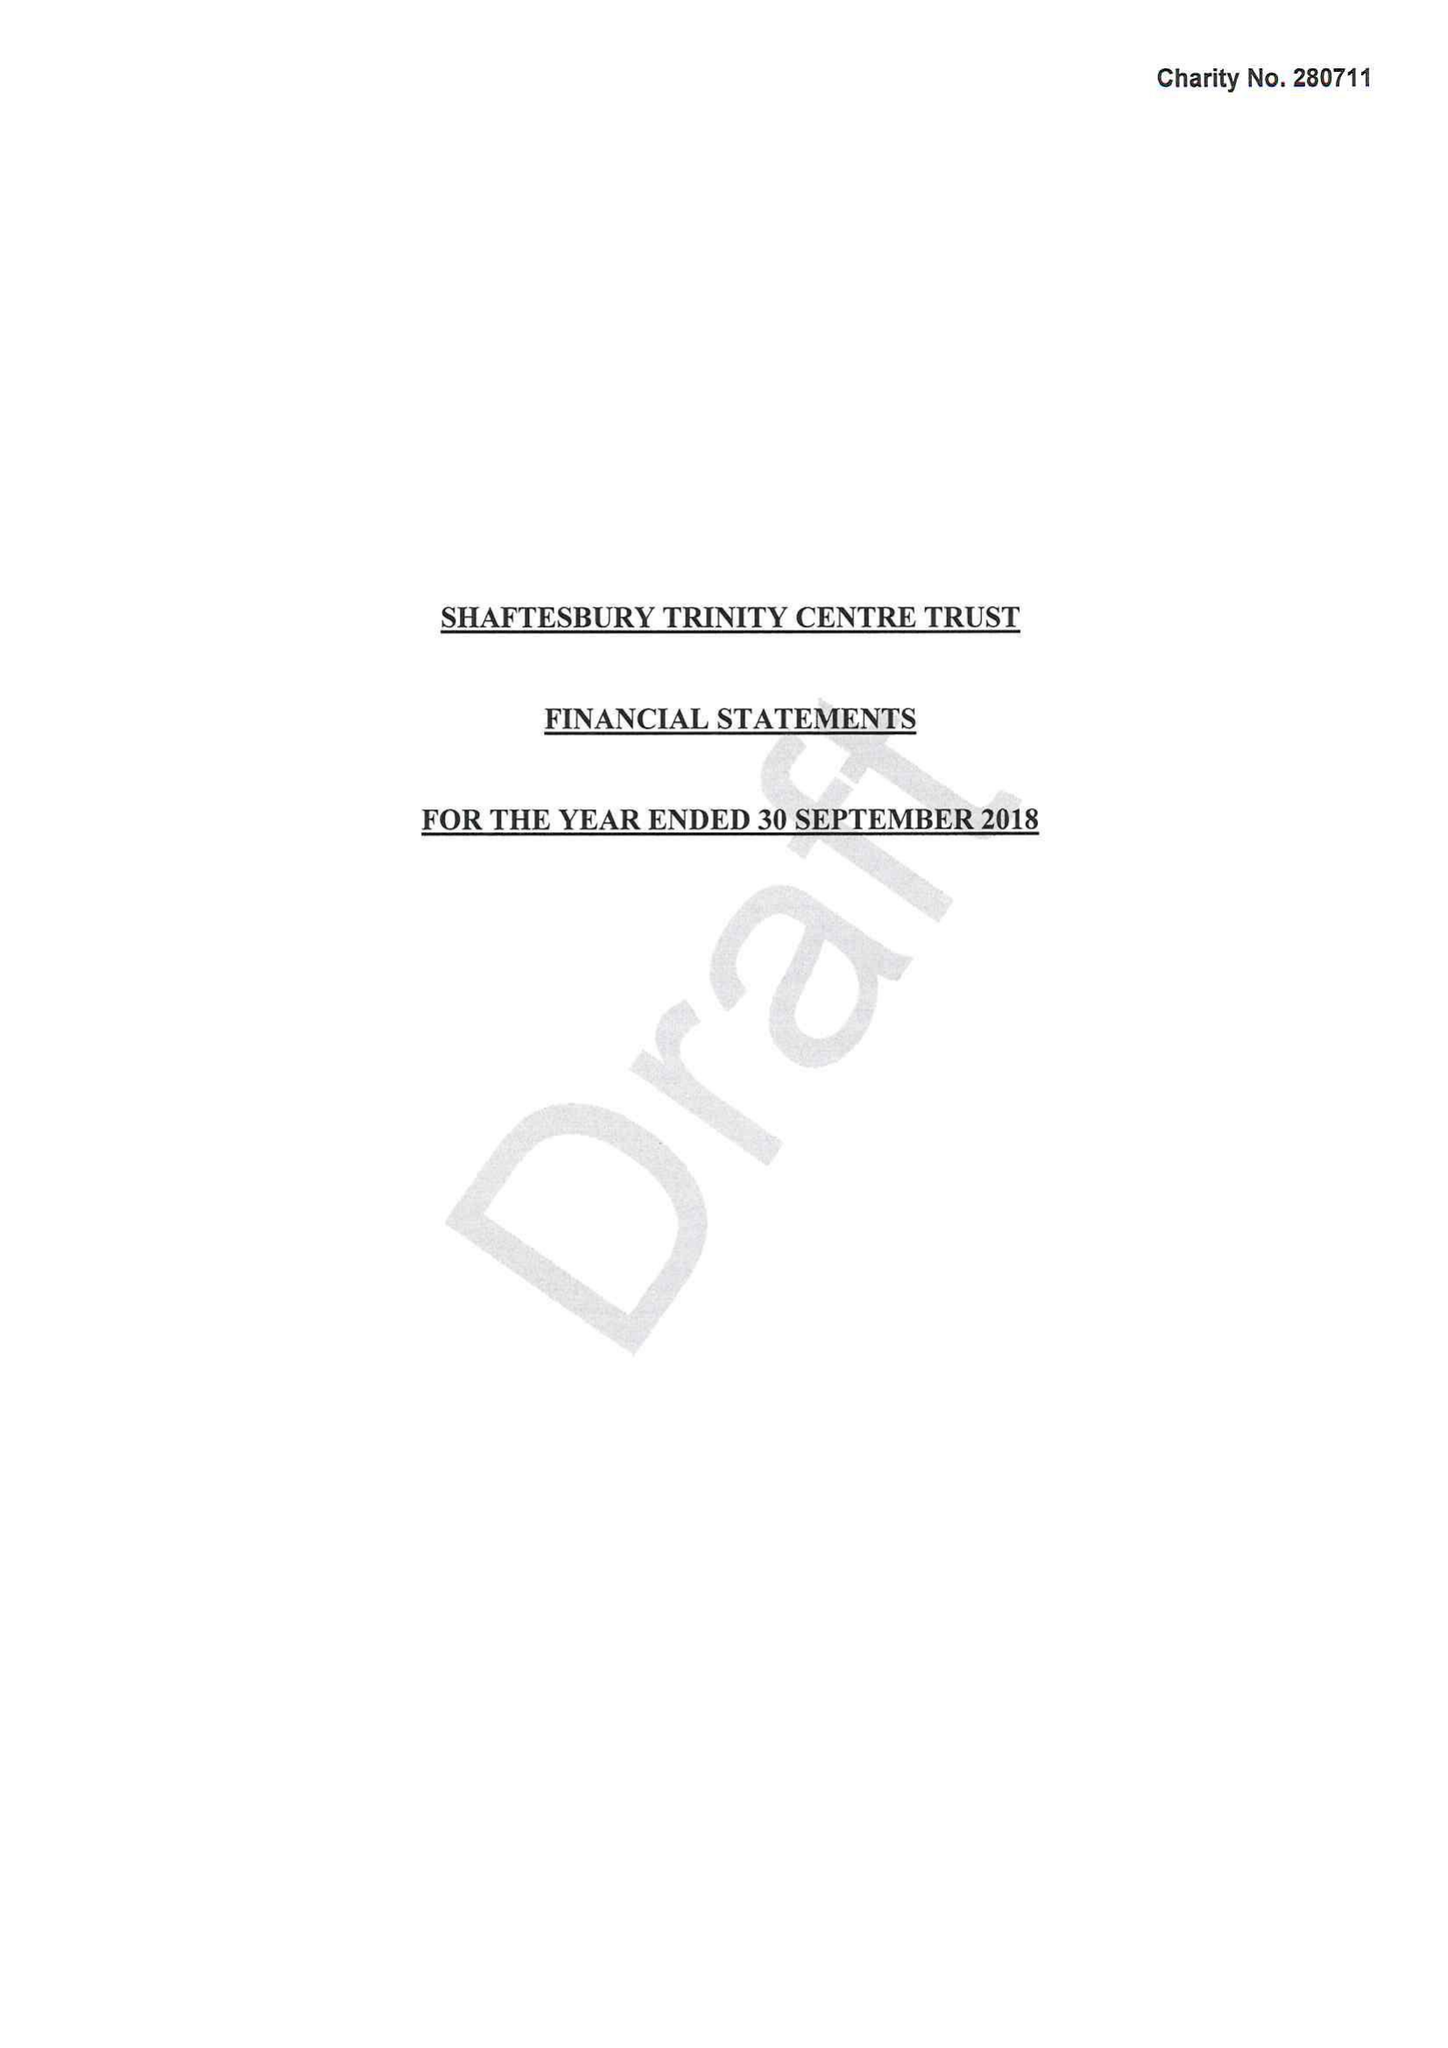What is the value for the income_annually_in_british_pounds?
Answer the question using a single word or phrase. 75037.00 